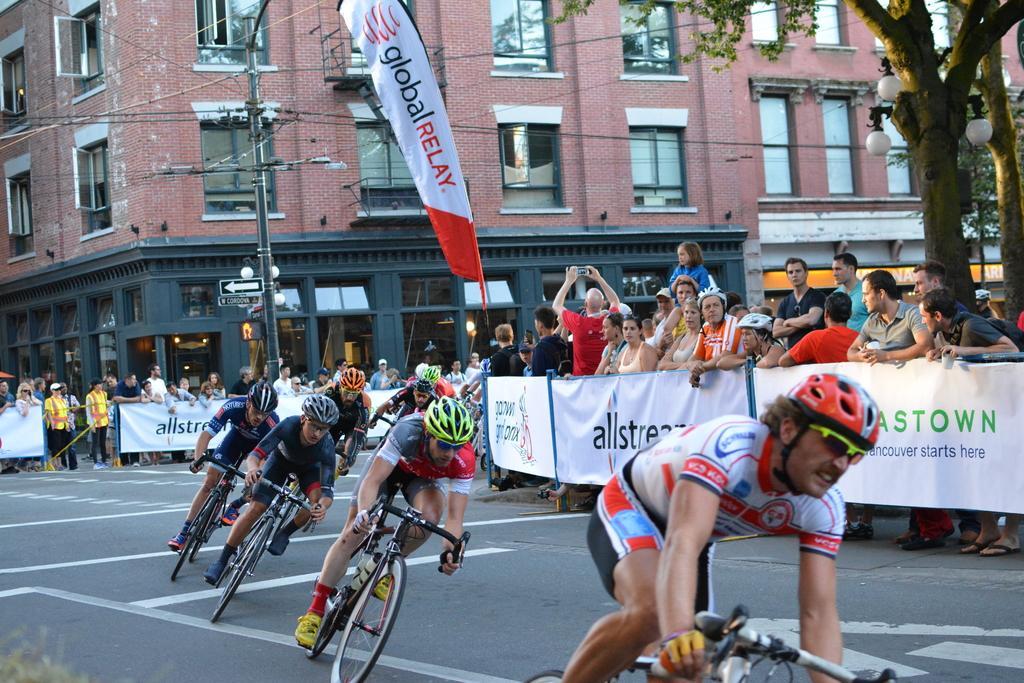How would you summarize this image in a sentence or two? Group of people standing and these persons are riding bicycle on the road and wear helmets. We can see building,glass window,pole,wires,banners,lights,trees. 